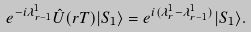Convert formula to latex. <formula><loc_0><loc_0><loc_500><loc_500>e ^ { - i \lambda _ { r - 1 } ^ { 1 } } \hat { U } ( r T ) | S _ { 1 } \rangle = e ^ { i ( \lambda _ { r } ^ { 1 } - \lambda _ { r - 1 } ^ { 1 } ) } | S _ { 1 } \rangle .</formula> 